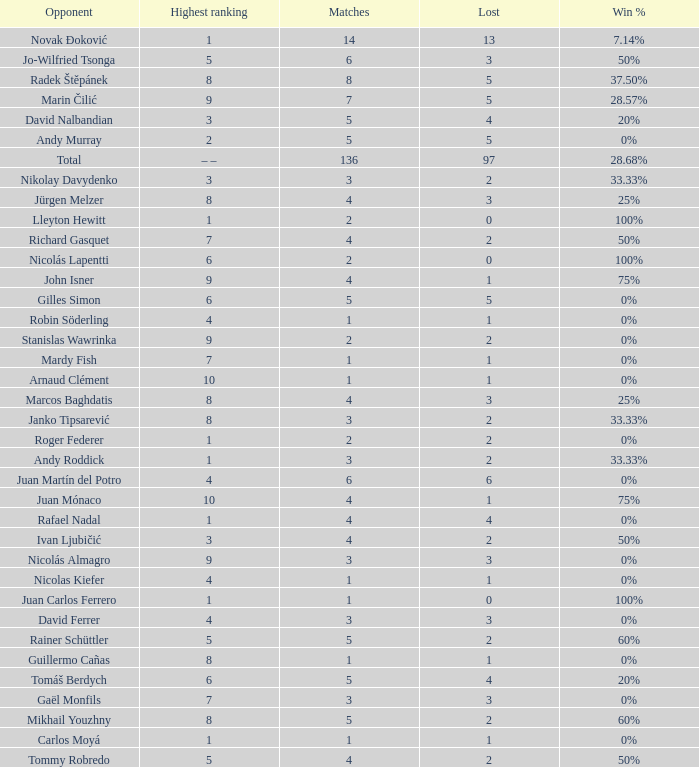What is the total number of Lost for the Highest Ranking of – –? 1.0. 